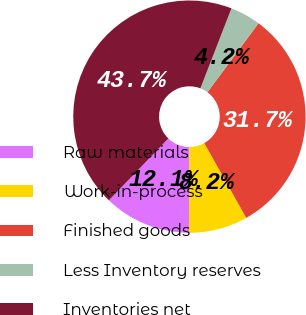Convert chart. <chart><loc_0><loc_0><loc_500><loc_500><pie_chart><fcel>Raw materials<fcel>Work-in-process<fcel>Finished goods<fcel>Less Inventory reserves<fcel>Inventories net<nl><fcel>12.14%<fcel>8.19%<fcel>31.72%<fcel>4.24%<fcel>43.71%<nl></chart> 